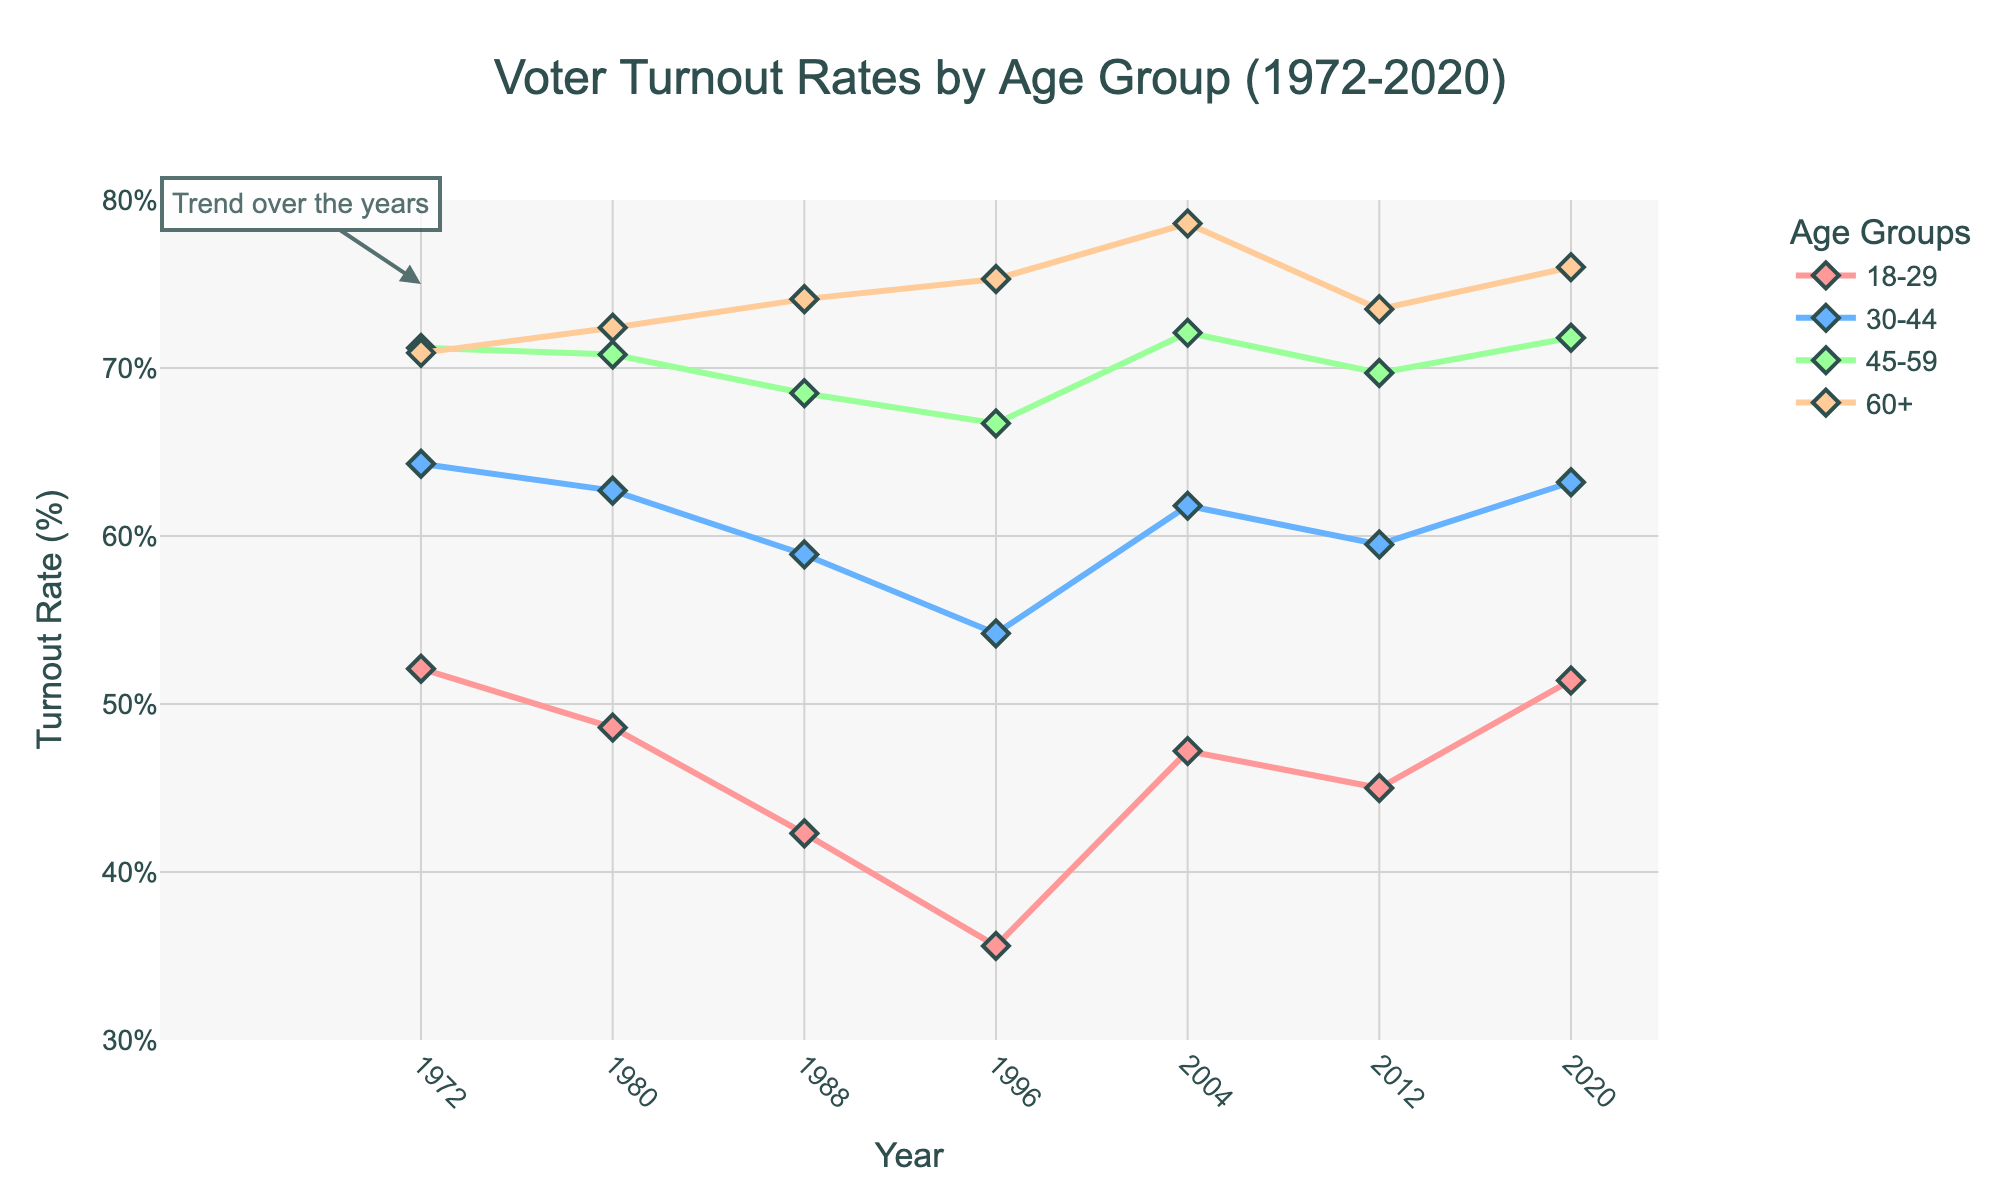Which age group had the highest voter turnout in 2020? To determine the highest voter turnout in 2020, observe the y-values at 2020 for all age groups. The age group 60+ has the highest y-value, indicating it had the highest voter turnout.
Answer: 60+ Did voter turnout for the 18-29 age group ever surpass the 45-59 age group? Examine the curves for the 18-29 and 45-59 age groups across all years. The 18-29 age group's voter turnout does not surpass that of the 45-59 age group in any year.
Answer: No How did the turnout rate for the 30-44 age group change between 1972 and 1996? Find the y-values for the 30-44 age group in 1972 and 1996. In 1972, it was 64.3%, and in 1996, it was 54.2%. Calculate the change: 64.3 - 54.2 = 10.1%.
Answer: Decreased by 10.1% Which year saw the lowest voter turnout for the 18-29 age group? Look for the lowest y-value in the 18-29 age group curve. The lowest point occurs in 1996 with a value of 35.6%.
Answer: 1996 What's the difference in turnout rates between the 60+ and 18-29 age groups in 1988? Check the y-values for 60+ and 18-29 age groups in 1988. The values are 74.1% and 42.3%, respectively. Calculate the difference: 74.1 - 42.3 = 31.8%.
Answer: 31.8% Did the voter turnout for the 45-59 age group show an increasing or decreasing trend from 2004 to 2012? Compare the y-values for the 45-59 age group in 2004 and 2012. In 2004, the value is 72.1%, and in 2012, it is 69.7%. The trend is decreasing.
Answer: Decreasing What is the average voter turnout rate of the 60+ age group from 1980 to 2004? Find the values for the 60+ age group in 1980, 1988, 1996, and 2004: 72.4%, 74.1%, 75.3%, 78.6%. Calculate the average: (72.4 + 74.1 + 75.3 + 78.6) / 4 = 75.1%.
Answer: 75.1% Which age group had the most consistent voter turnout rates over the years? Assess the visual smoothness and consistency of the lines for all age groups. The 60+ age group shows the least variation across the years, indicating the most consistent turnout.
Answer: 60+ 